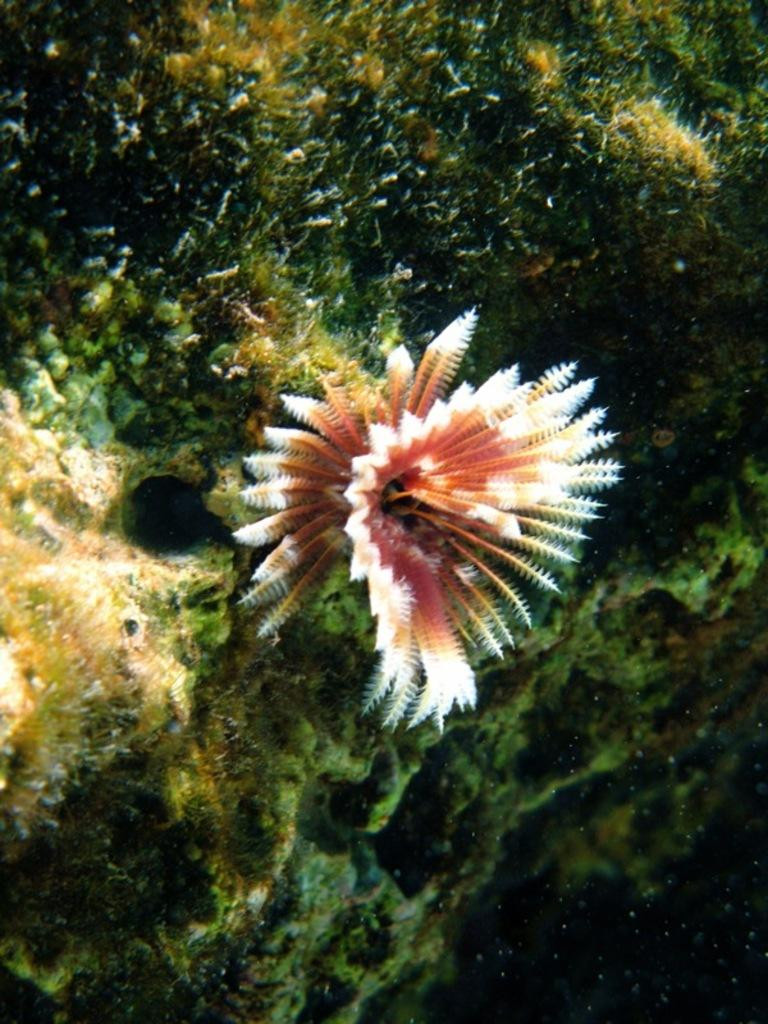What is the setting of the image? The image is underwater. What type of plant can be seen in the image? There is a flower in the image. What geological feature is present in the image? There is a rock in the image. What sense is the flower using to communicate with the rock in the image? There is no indication in the image that the flower or rock are communicating, and plants do not have senses like humans do. 